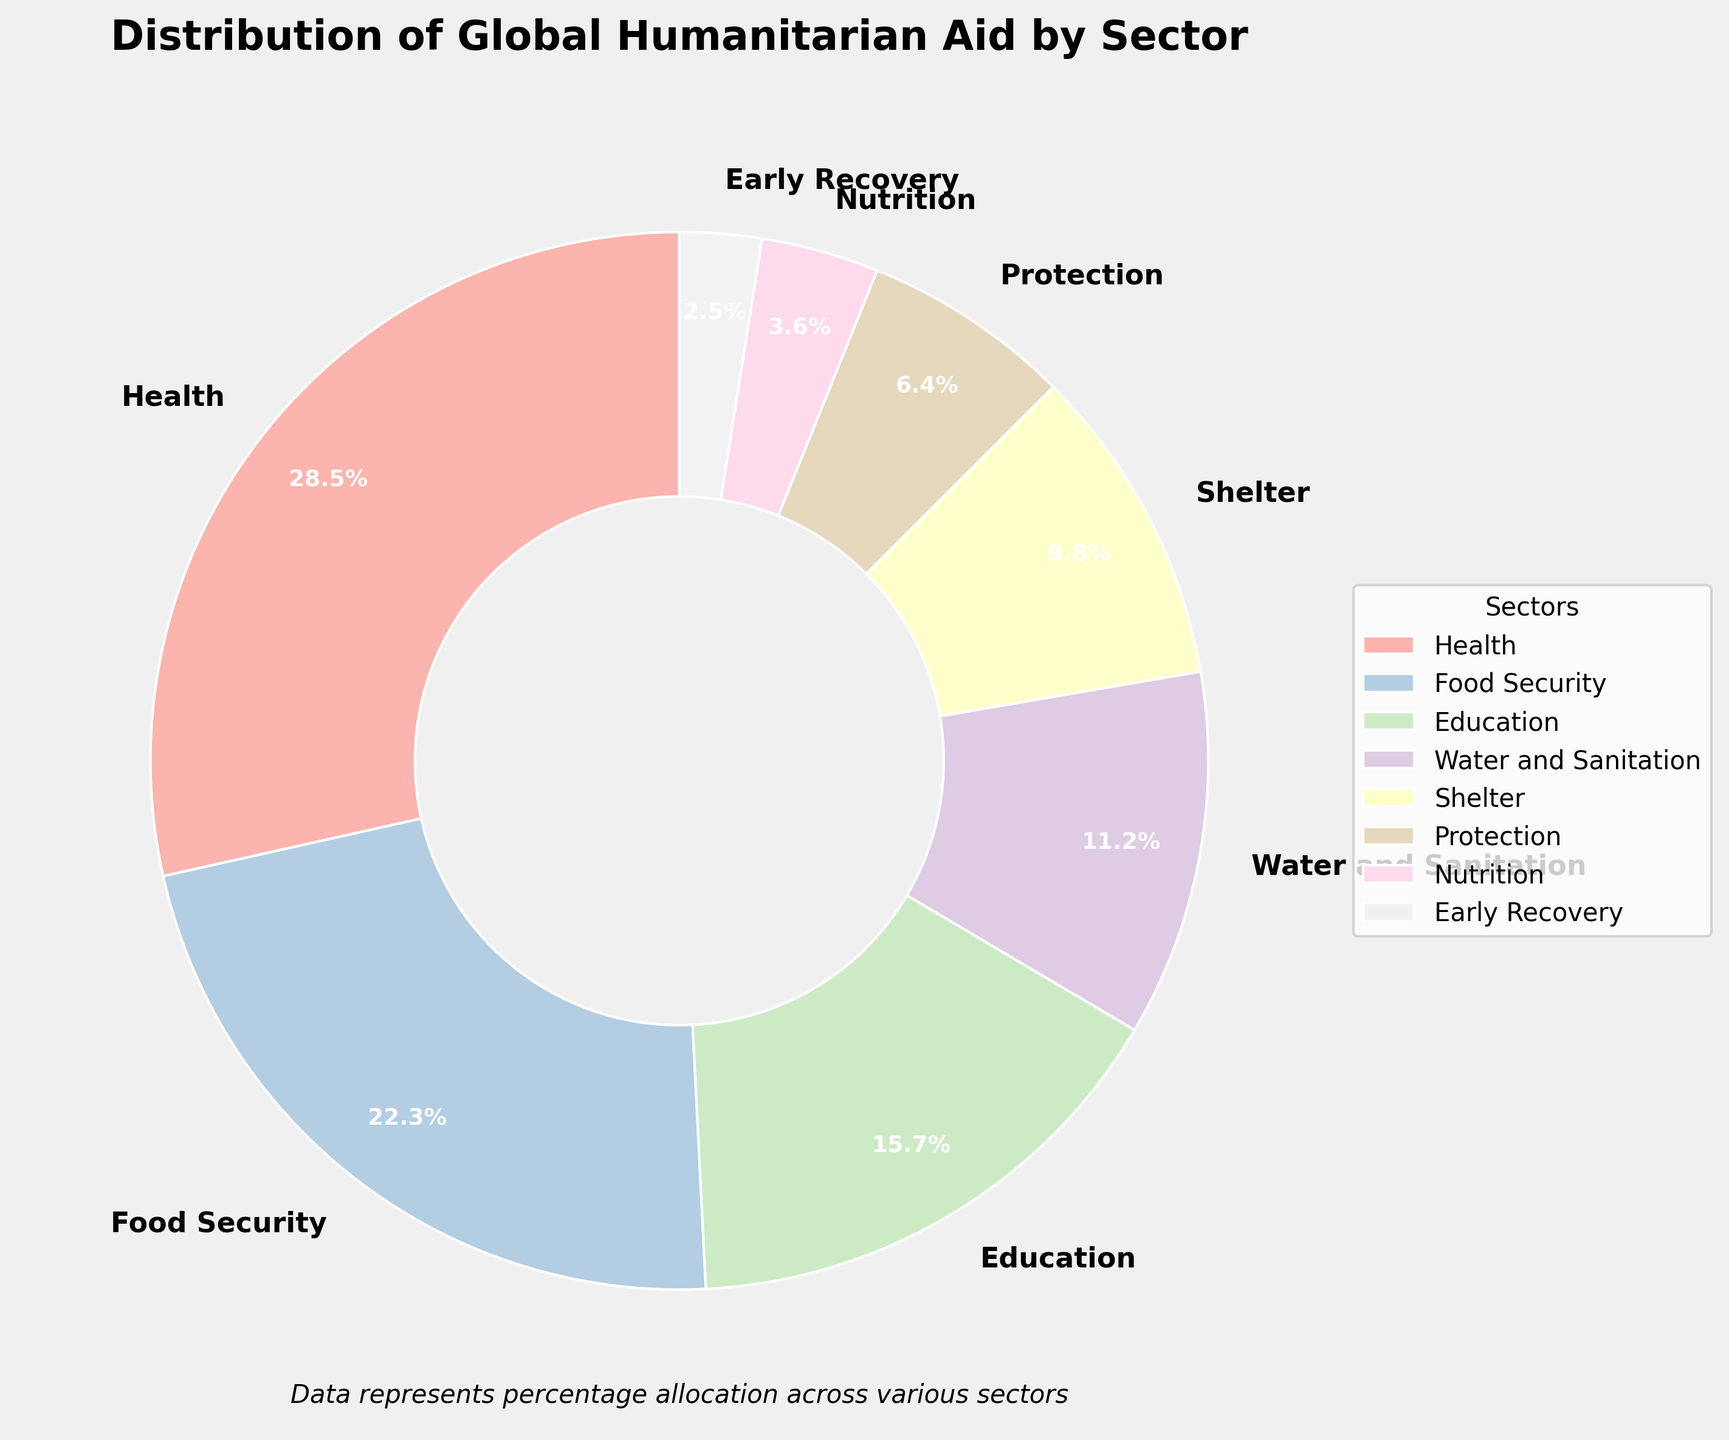What is the sector with the highest allocation percentage? By examining the pie chart, the sector with the largest wedge is identified. The Health sector has the largest allocation at 28.5%.
Answer: Health Which sectors together account for more than 50% of the total humanitarian aid? Adding the percentages of the sectors starting with the highest: Health (28.5%) + Food Security (22.3%) = 50.8%, which already exceeds 50%.
Answer: Health and Food Security What is the percentage difference between the sectors with the highest and lowest allocations? The sector with the highest allocation is Health (28.5%), and the lowest is Early Recovery (2.5%). Subtracting the percentages, 28.5% - 2.5% = 26%.
Answer: 26% If the percentages for Education and Shelter were combined, how would their total compare to Food Security? Adding the percentages of Education (15.7%) and Shelter (9.8%), 15.7% + 9.8% = 25.5%. Comparing this with Food Security (22.3%), 25.5% is greater.
Answer: Greater What is the combined percentage allocation for sectors related to basic survival needs (Health, Food Security, Water and Sanitation, Shelter)? Summing the percentages: Health (28.5%) + Food Security (22.3%) + Water and Sanitation (11.2%) + Shelter (9.8%), we get a total of 71.8%.
Answer: 71.8% How does the allocation to Protection compare to Nutrition? The allocation for Protection is 6.4%, while for Nutrition, it is 3.6%. 6.4% is greater than 3.6%.
Answer: Protection is greater Which sector has a smaller allocation than Education but larger than Nutrition? Education is allocated 15.7%, and Nutrition is 3.6%. The sector that has a percentage between these two is Protection at 6.4%.
Answer: Protection What is the total percentage for sectors receiving less than 10% of the aid each? The sectors below 10% are Shelter (9.8%), Protection (6.4%), Nutrition (3.6%), and Early Recovery (2.5%). Summing these: 9.8% + 6.4% + 3.6% + 2.5% = 22.3%.
Answer: 22.3% Which wedge is the third largest, and what is its percentage? The largest wedge is Health (28.5%), followed by Food Security (22.3%), making Education (15.7%) the third largest.
Answer: Education, 15.7% 